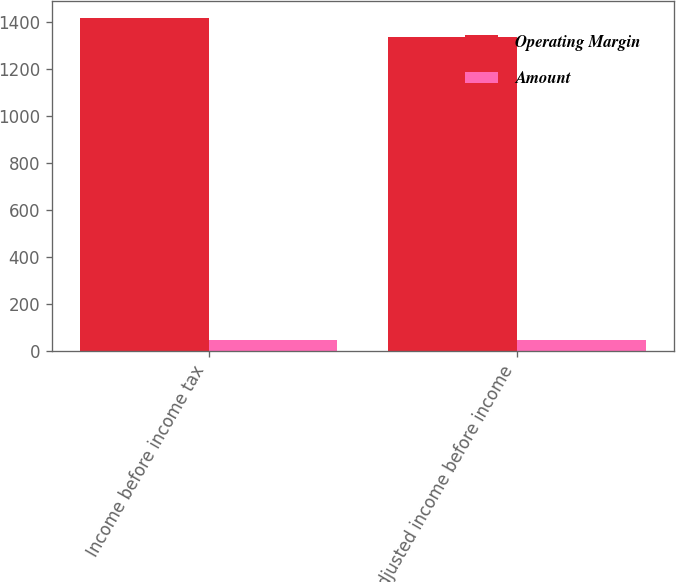Convert chart. <chart><loc_0><loc_0><loc_500><loc_500><stacked_bar_chart><ecel><fcel>Income before income tax<fcel>Adjusted income before income<nl><fcel>Operating Margin<fcel>1418<fcel>1336<nl><fcel>Amount<fcel>49<fcel>47<nl></chart> 